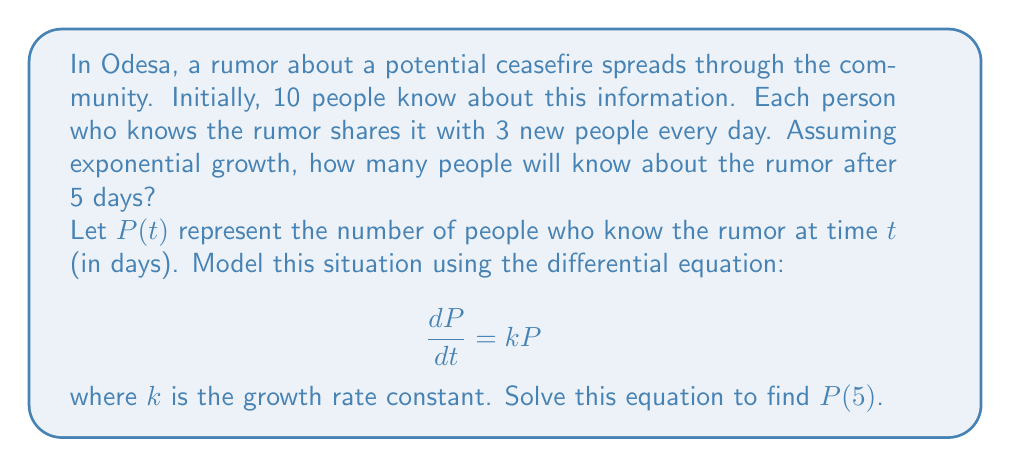Give your solution to this math problem. To solve this problem, we'll follow these steps:

1) First, we need to determine the growth rate constant $k$. Since each person shares the rumor with 3 new people every day, the population grows by 300% daily. This means:

   $k = 3 = 300\% = 3.00$ per day

2) The general solution for the exponential growth model is:

   $P(t) = P_0e^{kt}$

   where $P_0$ is the initial population (10 people in this case).

3) Substituting the values we know:

   $P(t) = 10e^{3t}$

4) To find the number of people who know the rumor after 5 days, we calculate $P(5)$:

   $P(5) = 10e^{3(5)} = 10e^{15}$

5) Using a calculator or computer to evaluate this:

   $P(5) \approx 32,690,173$ people

Note: This model assumes unlimited population growth, which is not realistic in practice. In a real scenario, the growth would eventually slow down as the rumor reaches most of the population (logistic growth model). However, for short-term predictions in a large population, the exponential model can be a good approximation.
Answer: After 5 days, approximately 32,690,173 people will know about the rumor. 